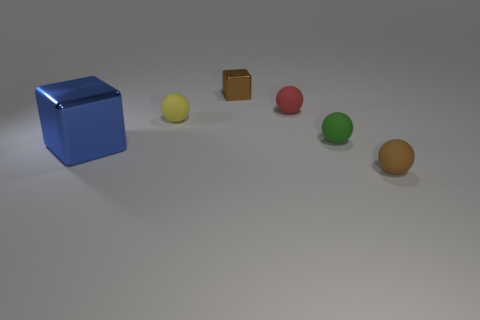What is the material of the other tiny thing that is the same color as the tiny metal thing?
Give a very brief answer. Rubber. Is the color of the large metal thing the same as the rubber object in front of the large blue thing?
Your response must be concise. No. What number of other objects are there of the same color as the large shiny block?
Ensure brevity in your answer.  0. What number of other objects are the same material as the red ball?
Provide a short and direct response. 3. There is a red object that is the same material as the small yellow thing; what is its shape?
Provide a short and direct response. Sphere. Is there anything else that is the same shape as the yellow thing?
Provide a short and direct response. Yes. There is a shiny object behind the block to the left of the tiny brown object behind the brown rubber thing; what color is it?
Your answer should be very brief. Brown. Is the number of spheres behind the brown matte object less than the number of shiny blocks that are right of the tiny green matte object?
Your response must be concise. No. Is the tiny metallic object the same shape as the blue thing?
Your answer should be very brief. Yes. What number of yellow cylinders have the same size as the brown ball?
Provide a succinct answer. 0. 